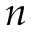<formula> <loc_0><loc_0><loc_500><loc_500>n</formula> 